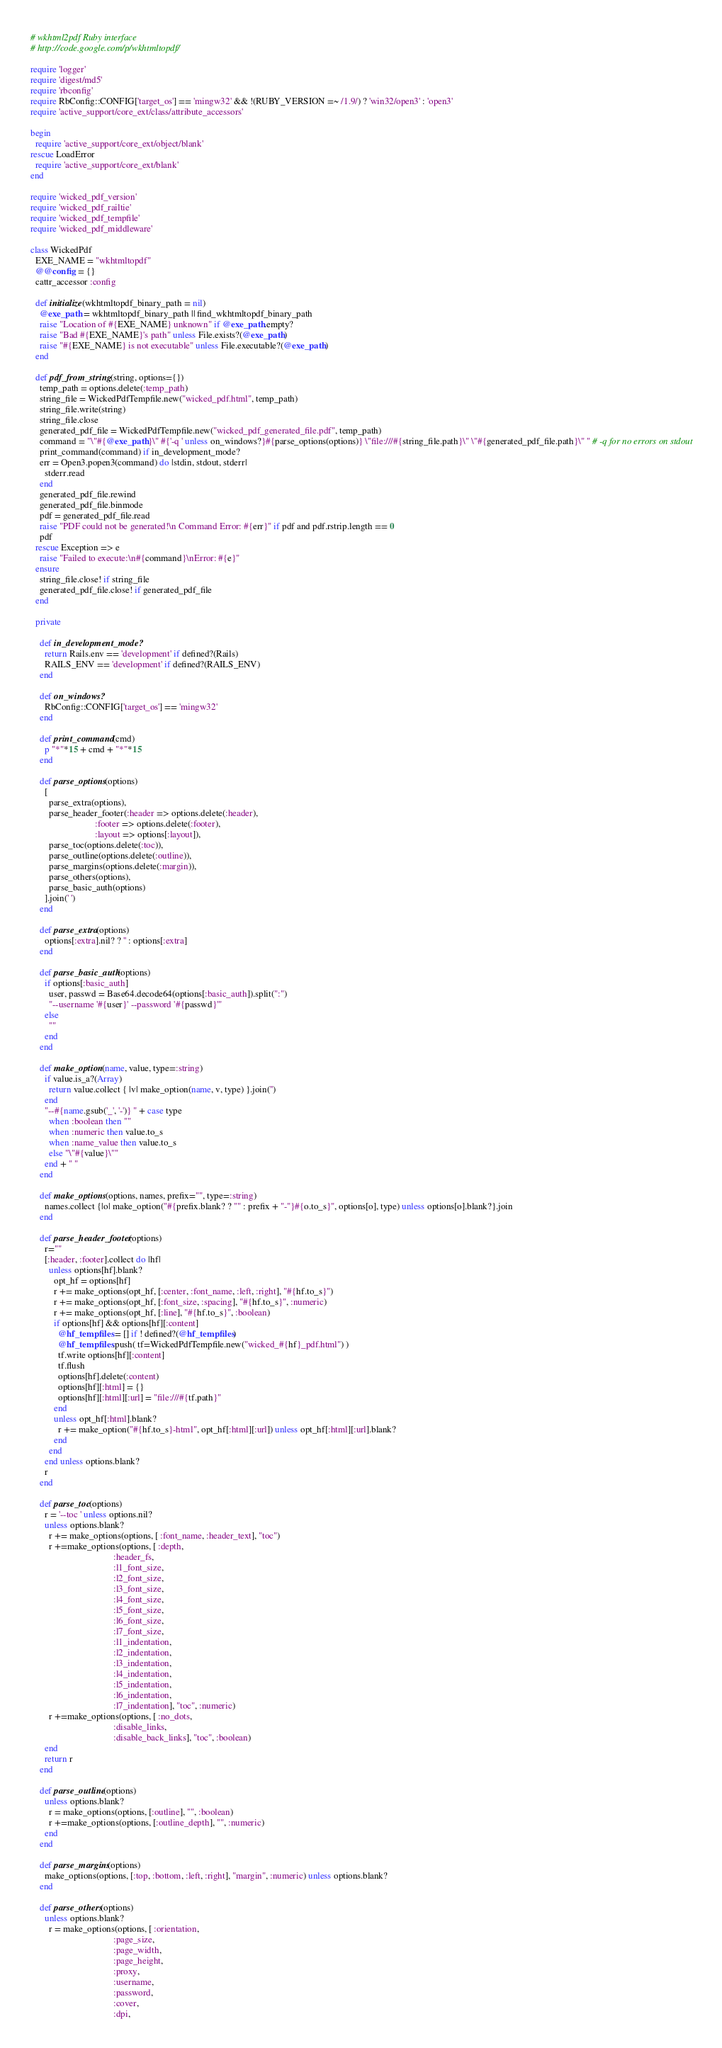<code> <loc_0><loc_0><loc_500><loc_500><_Ruby_># wkhtml2pdf Ruby interface
# http://code.google.com/p/wkhtmltopdf/

require 'logger'
require 'digest/md5'
require 'rbconfig'
require RbConfig::CONFIG['target_os'] == 'mingw32' && !(RUBY_VERSION =~ /1.9/) ? 'win32/open3' : 'open3'
require 'active_support/core_ext/class/attribute_accessors'

begin
  require 'active_support/core_ext/object/blank'
rescue LoadError
  require 'active_support/core_ext/blank'
end

require 'wicked_pdf_version'
require 'wicked_pdf_railtie'
require 'wicked_pdf_tempfile'
require 'wicked_pdf_middleware'

class WickedPdf
  EXE_NAME = "wkhtmltopdf"
  @@config = {}
  cattr_accessor :config

  def initialize(wkhtmltopdf_binary_path = nil)
    @exe_path = wkhtmltopdf_binary_path || find_wkhtmltopdf_binary_path
    raise "Location of #{EXE_NAME} unknown" if @exe_path.empty?
    raise "Bad #{EXE_NAME}'s path" unless File.exists?(@exe_path)
    raise "#{EXE_NAME} is not executable" unless File.executable?(@exe_path)
  end

  def pdf_from_string(string, options={})
    temp_path = options.delete(:temp_path)
    string_file = WickedPdfTempfile.new("wicked_pdf.html", temp_path)
    string_file.write(string)
    string_file.close
    generated_pdf_file = WickedPdfTempfile.new("wicked_pdf_generated_file.pdf", temp_path)
    command = "\"#{@exe_path}\" #{'-q ' unless on_windows?}#{parse_options(options)} \"file:///#{string_file.path}\" \"#{generated_pdf_file.path}\" " # -q for no errors on stdout
    print_command(command) if in_development_mode?
    err = Open3.popen3(command) do |stdin, stdout, stderr|
      stderr.read
    end
    generated_pdf_file.rewind
    generated_pdf_file.binmode
    pdf = generated_pdf_file.read
    raise "PDF could not be generated!\n Command Error: #{err}" if pdf and pdf.rstrip.length == 0
    pdf
  rescue Exception => e
    raise "Failed to execute:\n#{command}\nError: #{e}"
  ensure
    string_file.close! if string_file
    generated_pdf_file.close! if generated_pdf_file
  end

  private

    def in_development_mode?
      return Rails.env == 'development' if defined?(Rails)
      RAILS_ENV == 'development' if defined?(RAILS_ENV)
    end

    def on_windows?
      RbConfig::CONFIG['target_os'] == 'mingw32'
    end

    def print_command(cmd)
      p "*"*15 + cmd + "*"*15
    end

    def parse_options(options)
      [
        parse_extra(options),
        parse_header_footer(:header => options.delete(:header),
                            :footer => options.delete(:footer),
                            :layout => options[:layout]),
        parse_toc(options.delete(:toc)),
        parse_outline(options.delete(:outline)),
        parse_margins(options.delete(:margin)),
        parse_others(options),
        parse_basic_auth(options)
      ].join(' ')
    end

    def parse_extra(options)
      options[:extra].nil? ? '' : options[:extra]
    end

    def parse_basic_auth(options)
      if options[:basic_auth]
        user, passwd = Base64.decode64(options[:basic_auth]).split(":")
        "--username '#{user}' --password '#{passwd}'"
      else
        ""
      end
    end

    def make_option(name, value, type=:string)
      if value.is_a?(Array)
        return value.collect { |v| make_option(name, v, type) }.join('')
      end
      "--#{name.gsub('_', '-')} " + case type
        when :boolean then ""
        when :numeric then value.to_s
        when :name_value then value.to_s
        else "\"#{value}\""
      end + " "
    end

    def make_options(options, names, prefix="", type=:string)
      names.collect {|o| make_option("#{prefix.blank? ? "" : prefix + "-"}#{o.to_s}", options[o], type) unless options[o].blank?}.join
    end

    def parse_header_footer(options)
      r=""
      [:header, :footer].collect do |hf|
        unless options[hf].blank?
          opt_hf = options[hf]
          r += make_options(opt_hf, [:center, :font_name, :left, :right], "#{hf.to_s}")
          r += make_options(opt_hf, [:font_size, :spacing], "#{hf.to_s}", :numeric)
          r += make_options(opt_hf, [:line], "#{hf.to_s}", :boolean)
          if options[hf] && options[hf][:content]
            @hf_tempfiles = [] if ! defined?(@hf_tempfiles)
            @hf_tempfiles.push( tf=WickedPdfTempfile.new("wicked_#{hf}_pdf.html") )
            tf.write options[hf][:content]
            tf.flush
            options[hf].delete(:content)
            options[hf][:html] = {}
            options[hf][:html][:url] = "file:///#{tf.path}"
          end
          unless opt_hf[:html].blank?
            r += make_option("#{hf.to_s}-html", opt_hf[:html][:url]) unless opt_hf[:html][:url].blank?
          end
        end
      end unless options.blank?
      r
    end

    def parse_toc(options)
      r = '--toc ' unless options.nil?
      unless options.blank?
        r += make_options(options, [ :font_name, :header_text], "toc")
        r +=make_options(options, [ :depth,
                                    :header_fs,
                                    :l1_font_size,
                                    :l2_font_size,
                                    :l3_font_size,
                                    :l4_font_size,
                                    :l5_font_size,
                                    :l6_font_size,
                                    :l7_font_size,
                                    :l1_indentation,
                                    :l2_indentation,
                                    :l3_indentation,
                                    :l4_indentation,
                                    :l5_indentation,
                                    :l6_indentation,
                                    :l7_indentation], "toc", :numeric)
        r +=make_options(options, [ :no_dots,
                                    :disable_links,
                                    :disable_back_links], "toc", :boolean)
      end
      return r
    end

    def parse_outline(options)
      unless options.blank?
        r = make_options(options, [:outline], "", :boolean)
        r +=make_options(options, [:outline_depth], "", :numeric)
      end
    end

    def parse_margins(options)
      make_options(options, [:top, :bottom, :left, :right], "margin", :numeric) unless options.blank?
    end

    def parse_others(options)
      unless options.blank?
        r = make_options(options, [ :orientation,
                                    :page_size,
                                    :page_width,
                                    :page_height,
                                    :proxy,
                                    :username,
                                    :password,
                                    :cover,
                                    :dpi,</code> 